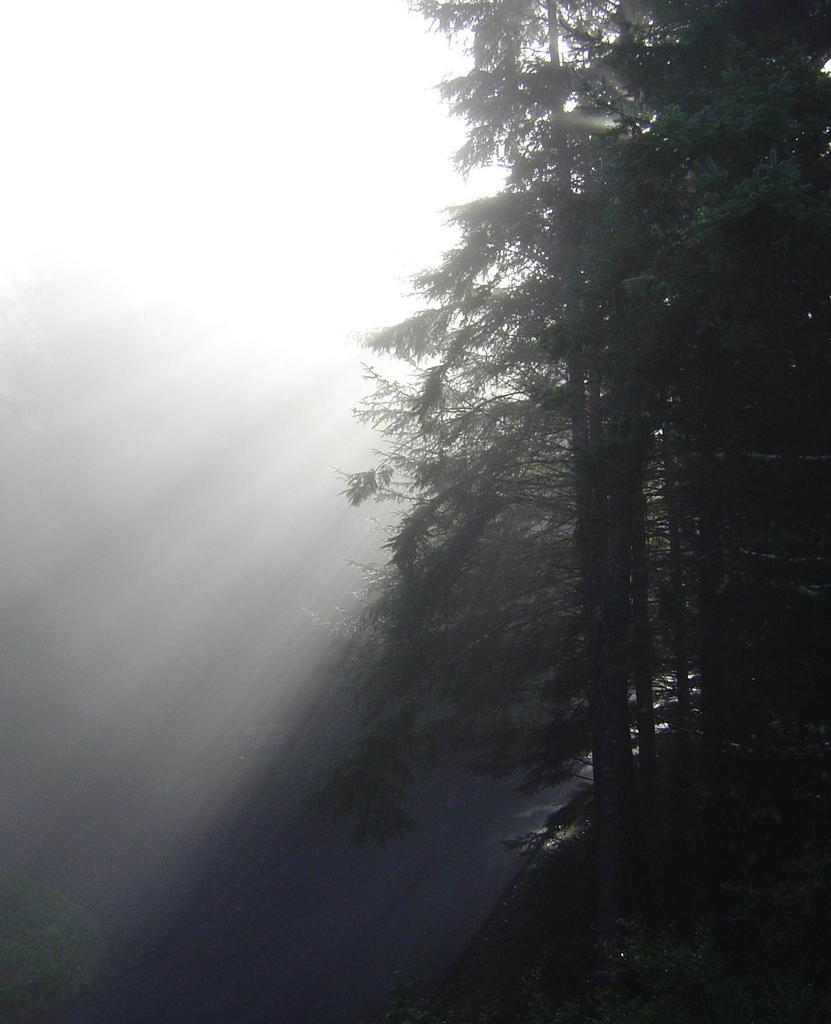What type of vegetation can be seen in the image? There is grass, plants, and trees in the image. What is the source of light in the image? Sunlight is visible in the image. What else is visible in the sky besides the sunlight? The sky is visible in the image. Based on the presence of sunlight, when do you think the image was taken? The image was likely taken during the day. What type of whistle can be heard in the image? There is no whistle present in the image, and therefore no sound can be heard. What type of sheet is covering the trees in the image? There is no sheet present in the image; the trees are not covered. 